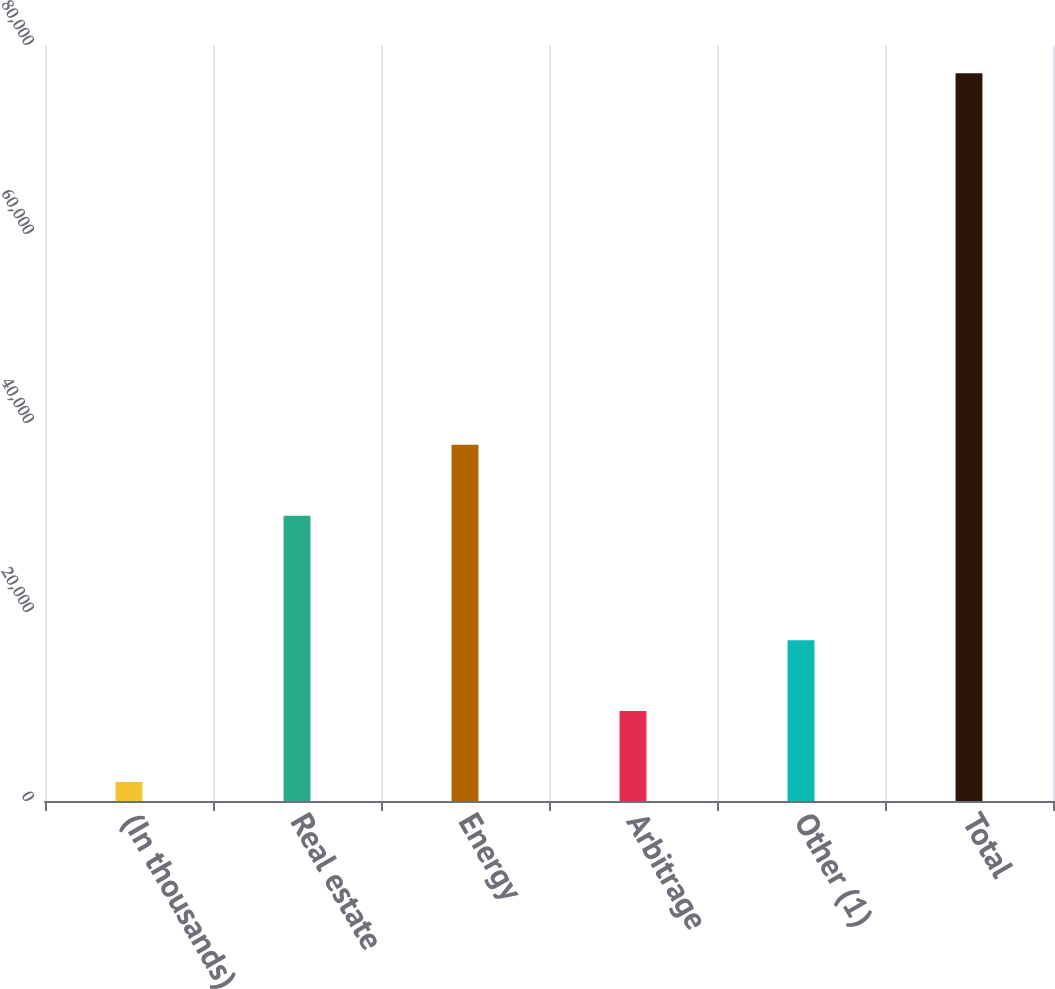Convert chart to OTSL. <chart><loc_0><loc_0><loc_500><loc_500><bar_chart><fcel>(In thousands)<fcel>Real estate<fcel>Energy<fcel>Arbitrage<fcel>Other (1)<fcel>Total<nl><fcel>2012<fcel>30196<fcel>37696.3<fcel>9512.3<fcel>17012.6<fcel>77015<nl></chart> 